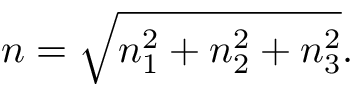<formula> <loc_0><loc_0><loc_500><loc_500>n = { \sqrt { n _ { 1 } ^ { 2 } + n _ { 2 } ^ { 2 } + n _ { 3 } ^ { 2 } } } .</formula> 